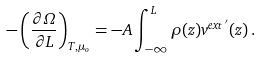<formula> <loc_0><loc_0><loc_500><loc_500>- \left ( \frac { \partial \Omega } { \partial L } \right ) _ { T , \mu _ { o } } = - A \int _ { - \infty } ^ { L } \rho ( z ) v ^ { e x t \, ^ { \prime } } ( z ) \, .</formula> 